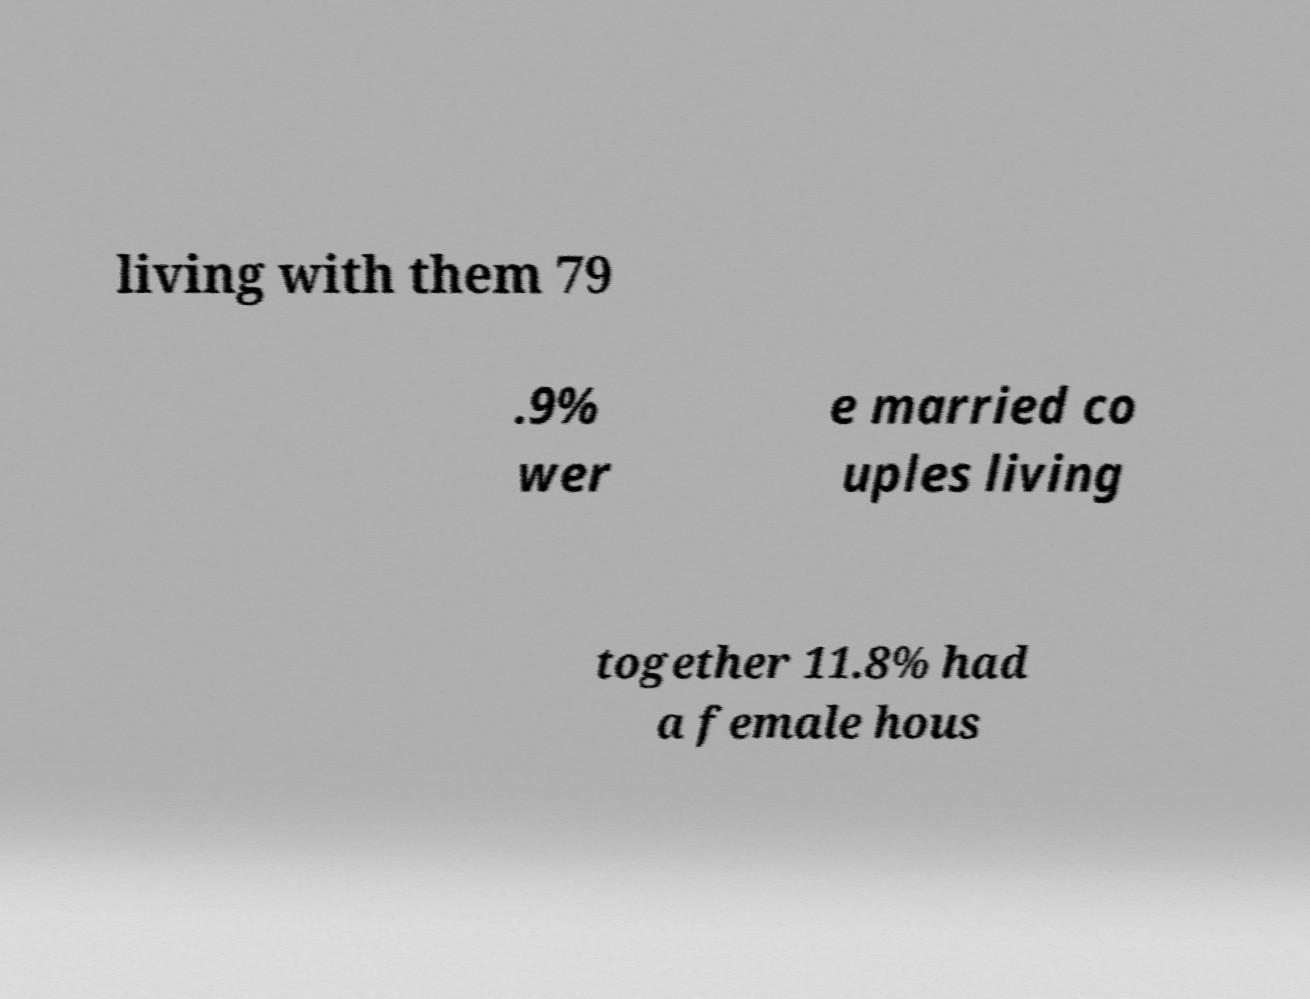Could you assist in decoding the text presented in this image and type it out clearly? living with them 79 .9% wer e married co uples living together 11.8% had a female hous 